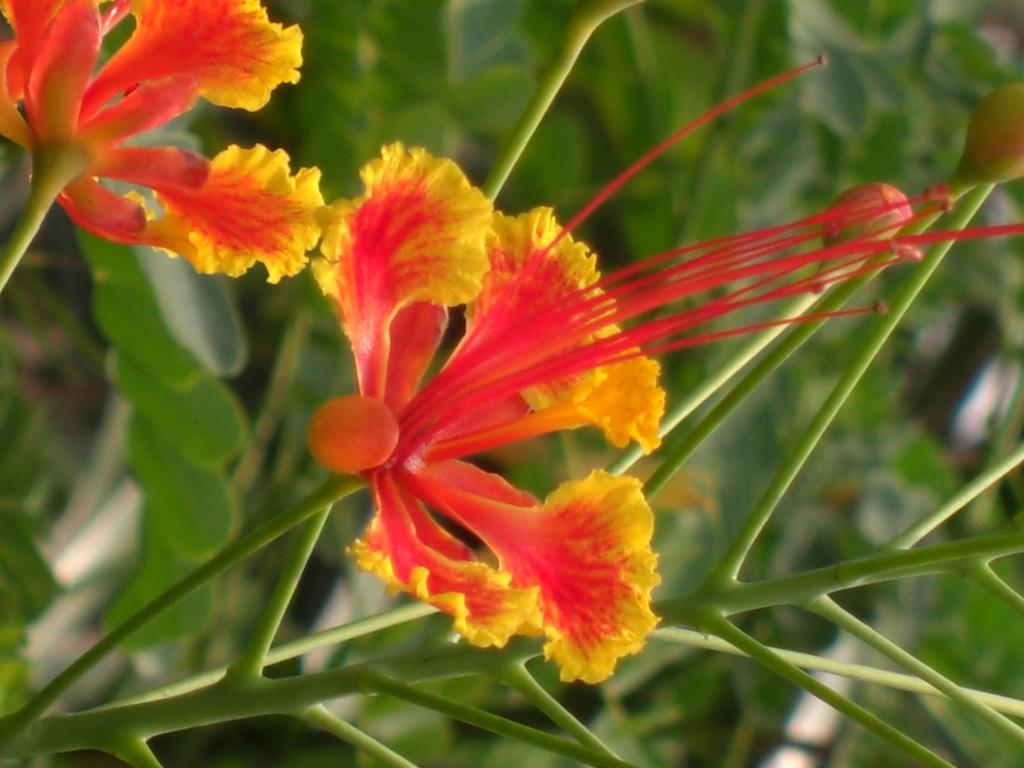What type of living organisms can be seen on the plant in the image? There are flowers on a plant in the image. Can you describe the plants visible in the background? Unfortunately, the provided facts do not mention any specific details about the plants in the background. How many ears of corn are visible in the image? There is no corn present in the image. What message of peace can be seen in the image? There is no reference to a message of peace in the image. 